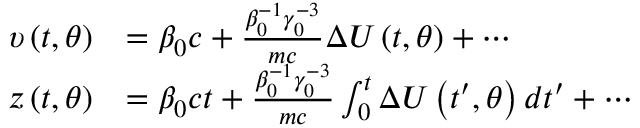Convert formula to latex. <formula><loc_0><loc_0><loc_500><loc_500>\begin{array} { r l } { \upsilon \left ( t , \theta \right ) } & { = \beta _ { 0 } c + \frac { \beta _ { 0 } ^ { - 1 } \gamma _ { 0 } ^ { - 3 } } { m c } \Delta U \left ( t , \theta \right ) + \cdots } \\ { z \left ( t , \theta \right ) } & { = \beta _ { 0 } c t + \frac { \beta _ { 0 } ^ { - 1 } \gamma _ { 0 } ^ { - 3 } } { m c } \int _ { 0 } ^ { t } \Delta U \left ( { t } ^ { \prime } , \theta \right ) d { t } ^ { \prime } + \cdots } \end{array}</formula> 